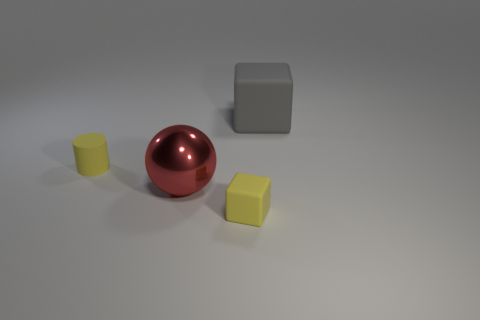Subtract all blue spheres. How many purple cubes are left? 0 Add 3 big gray things. How many big gray things exist? 4 Add 1 small green things. How many objects exist? 5 Subtract all yellow cubes. How many cubes are left? 1 Subtract 0 red cylinders. How many objects are left? 4 Subtract all cylinders. How many objects are left? 3 Subtract 1 balls. How many balls are left? 0 Subtract all cyan cubes. Subtract all gray cylinders. How many cubes are left? 2 Subtract all small objects. Subtract all tiny red metal spheres. How many objects are left? 2 Add 3 big gray matte objects. How many big gray matte objects are left? 4 